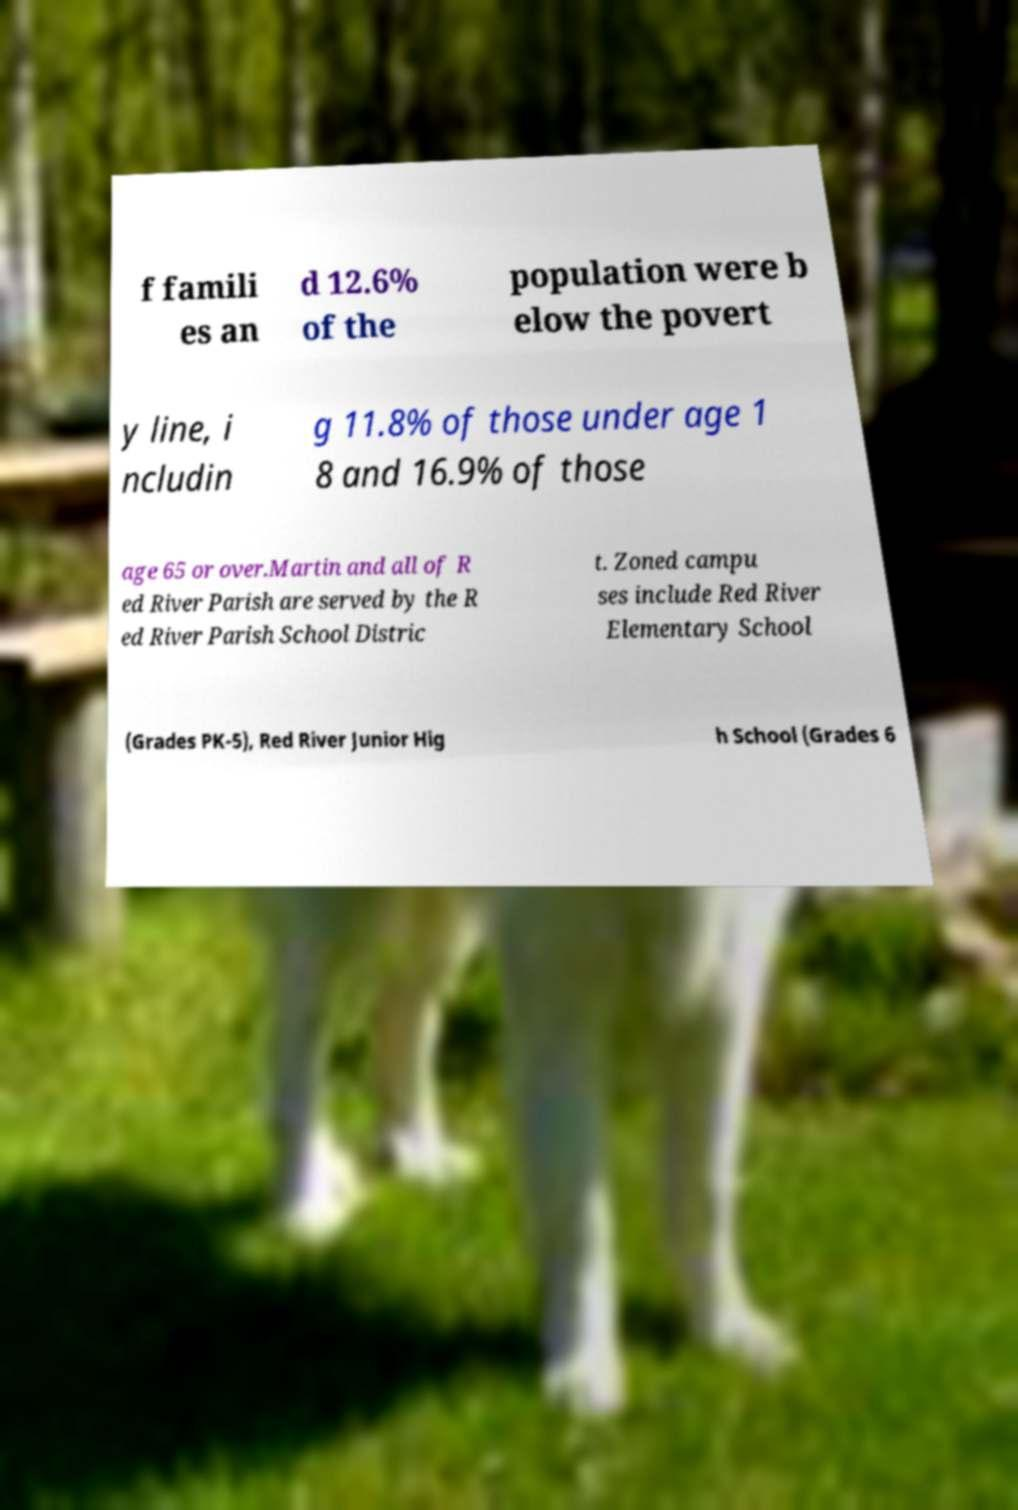Could you extract and type out the text from this image? f famili es an d 12.6% of the population were b elow the povert y line, i ncludin g 11.8% of those under age 1 8 and 16.9% of those age 65 or over.Martin and all of R ed River Parish are served by the R ed River Parish School Distric t. Zoned campu ses include Red River Elementary School (Grades PK-5), Red River Junior Hig h School (Grades 6 